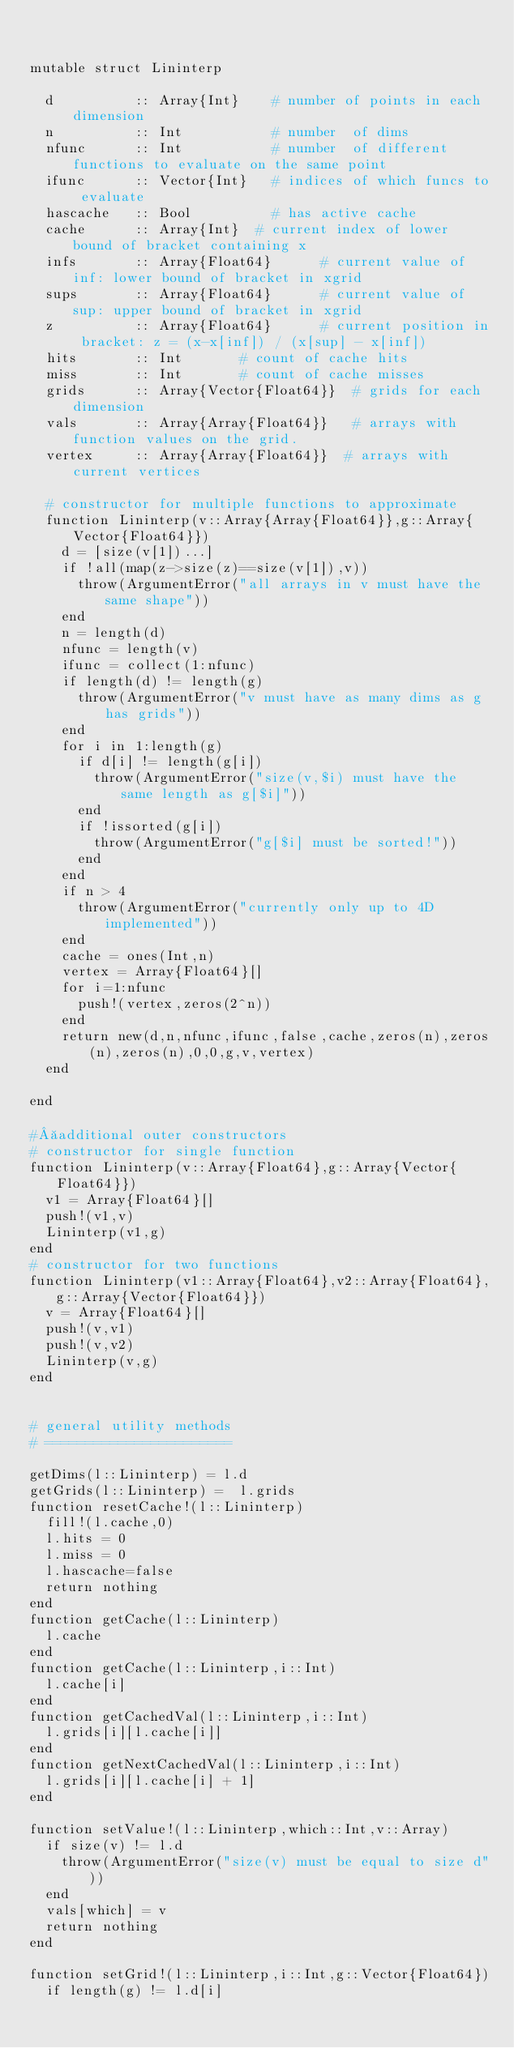Convert code to text. <code><loc_0><loc_0><loc_500><loc_500><_Julia_>

mutable struct Lininterp

	d          :: Array{Int}    # number of points in each dimension
	n          :: Int 	        # number  of dims
	nfunc      :: Int 	        # number  of different functions to evaluate on the same point
	ifunc      :: Vector{Int} 	# indices of which funcs to evaluate
	hascache   :: Bool 	        # has active cache
	cache      :: Array{Int}	# current index of lower bound of bracket containing x
	infs       :: Array{Float64}	    # current value of inf: lower bound of bracket in xgrid
	sups       :: Array{Float64}	   	# current value of sup: upper bound of bracket in xgrid
	z          :: Array{Float64}    	# current position in bracket: z = (x-x[inf]) / (x[sup] - x[inf])
	hits       :: Int 			# count of cache hits
	miss       :: Int 			# count of cache misses
	grids      :: Array{Vector{Float64}} 	# grids for each dimension
	vals       :: Array{Array{Float64}} 	# arrays with function values on the grid.
	vertex     :: Array{Array{Float64}}  # arrays with current vertices

	# constructor for multiple functions to approximate
	function Lininterp(v::Array{Array{Float64}},g::Array{Vector{Float64}})
		d = [size(v[1])...]
		if !all(map(z->size(z)==size(v[1]),v))
			throw(ArgumentError("all arrays in v must have the same shape"))
		end
		n = length(d)
		nfunc = length(v)
		ifunc = collect(1:nfunc)
		if length(d) != length(g)
			throw(ArgumentError("v must have as many dims as g has grids"))
		end
		for i in 1:length(g)
			if d[i] != length(g[i])
				throw(ArgumentError("size(v,$i) must have the same length as g[$i]"))
			end
			if !issorted(g[i])
				throw(ArgumentError("g[$i] must be sorted!"))
			end
		end
		if n > 4
			throw(ArgumentError("currently only up to 4D implemented"))
		end
		cache = ones(Int,n)
		vertex = Array{Float64}[]
		for i=1:nfunc
			push!(vertex,zeros(2^n))
		end
		return new(d,n,nfunc,ifunc,false,cache,zeros(n),zeros(n),zeros(n),0,0,g,v,vertex)
	end

end

# additional outer constructors
# constructor for single function
function Lininterp(v::Array{Float64},g::Array{Vector{Float64}})
	v1 = Array{Float64}[]
	push!(v1,v)
	Lininterp(v1,g)
end
# constructor for two functions
function Lininterp(v1::Array{Float64},v2::Array{Float64},g::Array{Vector{Float64}})
	v = Array{Float64}[]
	push!(v,v1)
	push!(v,v2)
	Lininterp(v,g)
end


# general utility methods
# =======================

getDims(l::Lininterp) = l.d 
getGrids(l::Lininterp) =  l.grids 
function resetCache!(l::Lininterp) 
	fill!(l.cache,0)
	l.hits = 0
	l.miss = 0
	l.hascache=false
	return nothing
end
function getCache(l::Lininterp)
	l.cache
end
function getCache(l::Lininterp,i::Int)
	l.cache[i]
end
function getCachedVal(l::Lininterp,i::Int)
	l.grids[i][l.cache[i]]
end
function getNextCachedVal(l::Lininterp,i::Int)
	l.grids[i][l.cache[i] + 1]
end

function setValue!(l::Lininterp,which::Int,v::Array)
	if size(v) != l.d
		throw(ArgumentError("size(v) must be equal to size d"))
	end
	vals[which] = v
	return nothing
end

function setGrid!(l::Lininterp,i::Int,g::Vector{Float64})
	if length(g) != l.d[i]</code> 